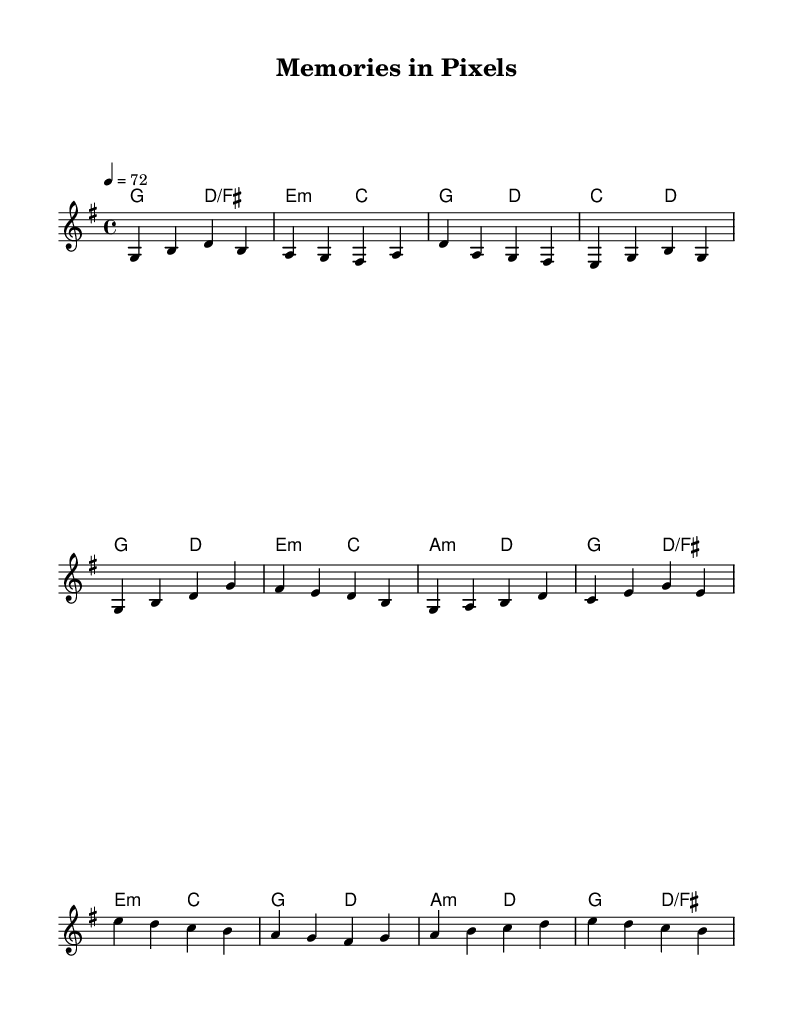What is the key signature of this music? The key signature is indicated at the beginning of the sheet music and shows one sharp, which corresponds to G major.
Answer: G major What is the time signature of this music? The time signature is found near the beginning of the sheet music and is displayed as 4/4, meaning there are four beats in a measure.
Answer: 4/4 What is the tempo marking for this piece? The tempo marking appears in the sheet music as "4 = 72", indicating that a quarter note gets 72 beats per minute.
Answer: 72 How many measures are in the verse section? The verse section consists of four lines of music; counting each line's measures gives a total of four measures in the verse.
Answer: 4 What chords are used in the chorus? By looking at the harmonies written underneath the melody, the chords in the chorus are G, E minor, A minor, and D, which are indicated beneath each melody note.
Answer: G, E minor, A minor, D Which section is labeled as the bridge? The section labeled as the bridge is identified in the music and appears after the chorus, consisting of specific musical material that differs from the rest.
Answer: Bridge How is the melody structured in terms of sections? The melody is structured into three distinct sections: a verse, followed by a chorus, and concluding with a bridge. The sections are separated by the corresponding lines in the music.
Answer: Verse, Chorus, Bridge 